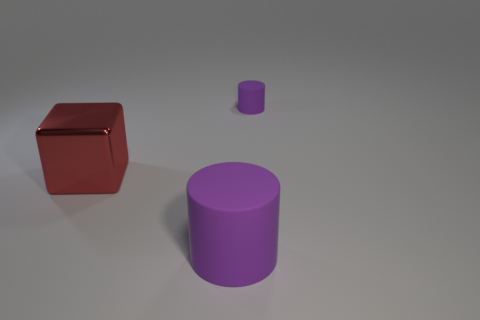Add 1 large purple matte objects. How many objects exist? 4 Add 2 big cylinders. How many big cylinders exist? 3 Subtract 0 green cylinders. How many objects are left? 3 Subtract all cylinders. How many objects are left? 1 Subtract 1 cubes. How many cubes are left? 0 Subtract all cyan cubes. Subtract all blue cylinders. How many cubes are left? 1 Subtract all yellow spheres. How many cyan cubes are left? 0 Subtract all big shiny blocks. Subtract all matte cylinders. How many objects are left? 0 Add 3 tiny purple things. How many tiny purple things are left? 4 